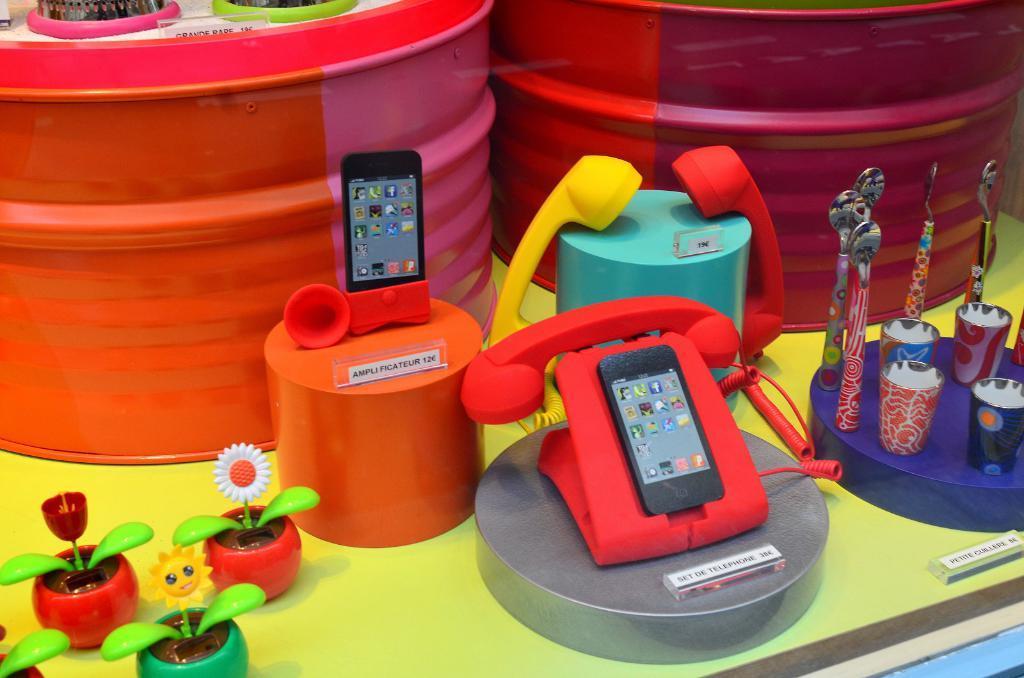Please provide a concise description of this image. In this picture we can see drums, toys like mobiles, telephones, spoons, glasses, flower pots and these all are placed on a green platform. 